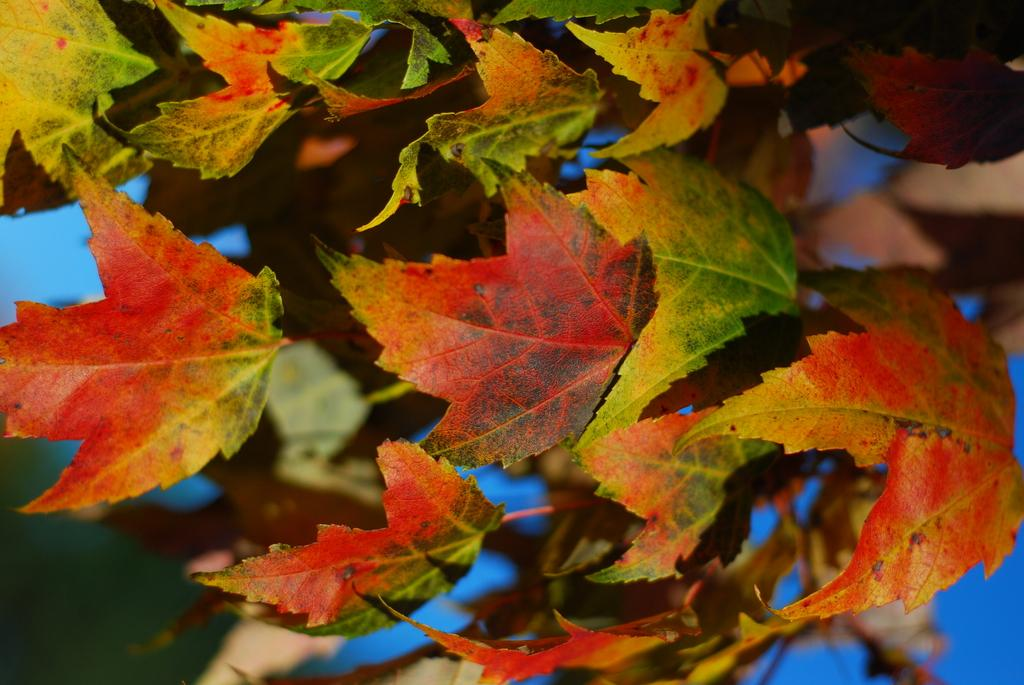What type of vegetation can be seen in the image? There are leaves in the image. Can you describe the color or texture of the leaves? The color and texture of the leaves cannot be determined from the image alone. Are the leaves attached to any plants or trees? The image does not show the leaves attached to any plants or trees. What caption is written on the leaves in the image? There is no caption written on the leaves in the image, as leaves do not have the ability to have writing on them. 